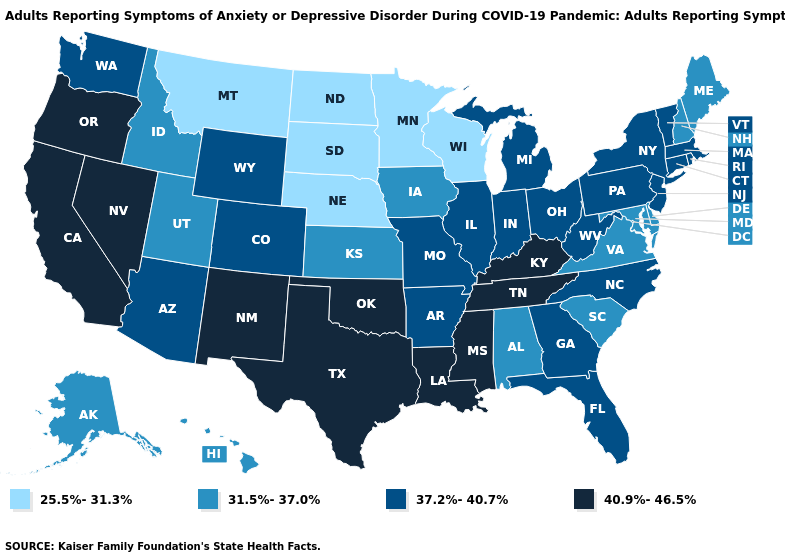What is the highest value in the West ?
Be succinct. 40.9%-46.5%. What is the value of Wisconsin?
Short answer required. 25.5%-31.3%. What is the lowest value in states that border Michigan?
Be succinct. 25.5%-31.3%. Does the first symbol in the legend represent the smallest category?
Short answer required. Yes. Does Oregon have the same value as Nevada?
Quick response, please. Yes. Which states have the lowest value in the South?
Give a very brief answer. Alabama, Delaware, Maryland, South Carolina, Virginia. What is the value of Alaska?
Answer briefly. 31.5%-37.0%. Does the first symbol in the legend represent the smallest category?
Keep it brief. Yes. What is the value of Oregon?
Keep it brief. 40.9%-46.5%. Name the states that have a value in the range 31.5%-37.0%?
Write a very short answer. Alabama, Alaska, Delaware, Hawaii, Idaho, Iowa, Kansas, Maine, Maryland, New Hampshire, South Carolina, Utah, Virginia. What is the lowest value in states that border Nebraska?
Quick response, please. 25.5%-31.3%. What is the value of Ohio?
Keep it brief. 37.2%-40.7%. Name the states that have a value in the range 31.5%-37.0%?
Answer briefly. Alabama, Alaska, Delaware, Hawaii, Idaho, Iowa, Kansas, Maine, Maryland, New Hampshire, South Carolina, Utah, Virginia. Name the states that have a value in the range 25.5%-31.3%?
Write a very short answer. Minnesota, Montana, Nebraska, North Dakota, South Dakota, Wisconsin. Which states have the lowest value in the USA?
Quick response, please. Minnesota, Montana, Nebraska, North Dakota, South Dakota, Wisconsin. 